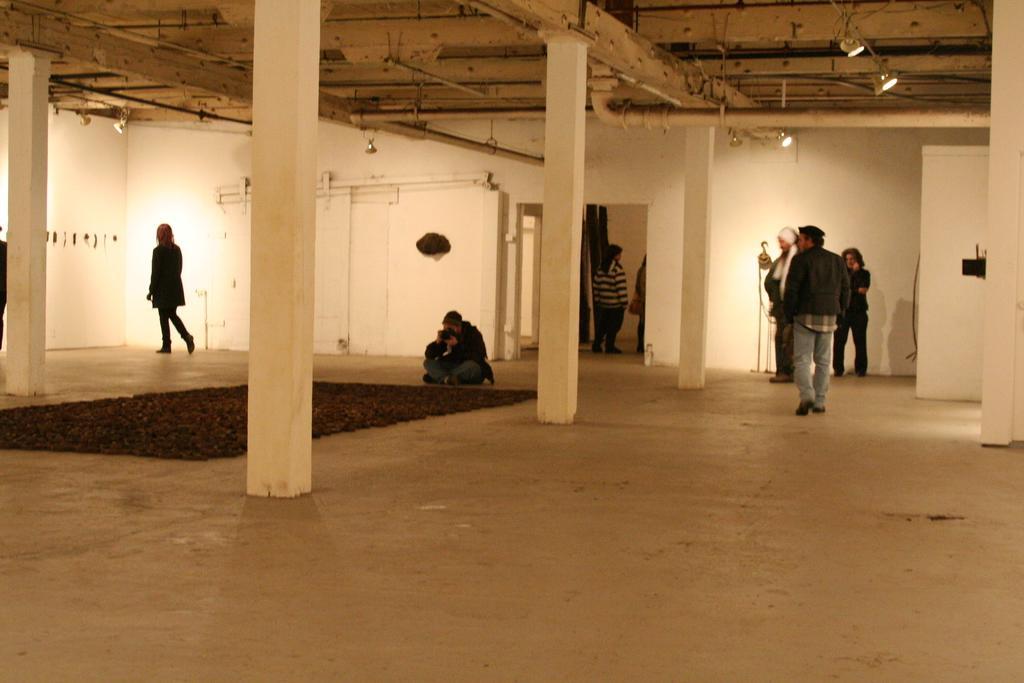Please provide a concise description of this image. In this image there are people under the roof. On the right side of the image there is a door. There are pillars. On top of the image there are lights. In the background of the image there is a wall. At the bottom of the image there is a mat on the floor. 